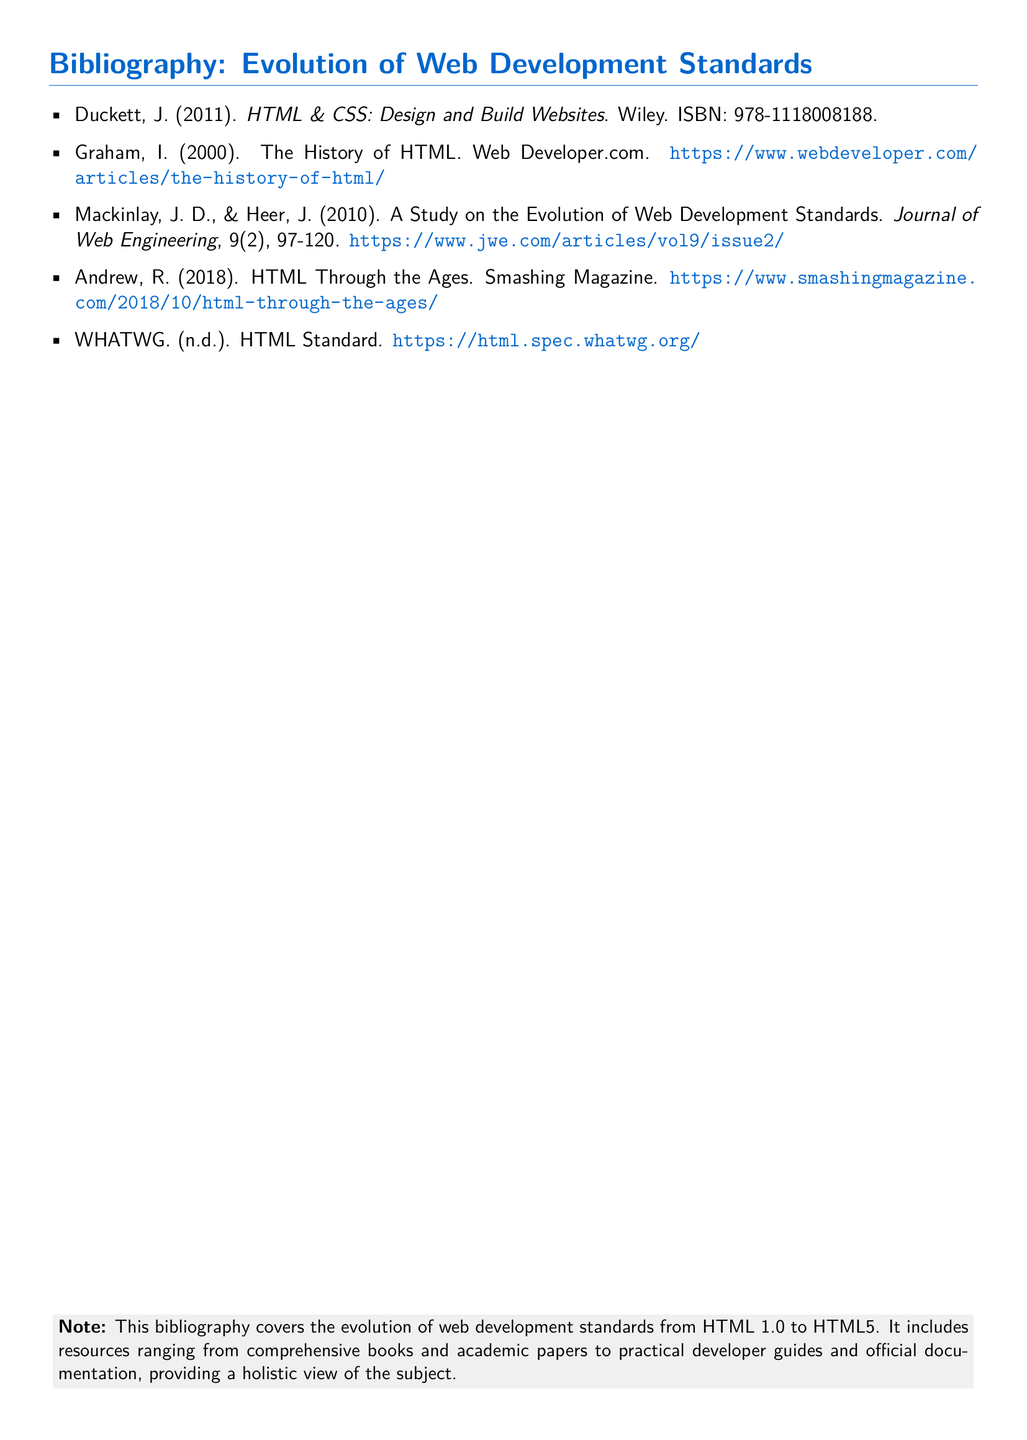What is the title of the first reference? The first reference in the document is titled "HTML & CSS: Design and Build Websites".
Answer: HTML & CSS: Design and Build Websites Who is the author of the second reference? The author listed for the second reference is Ian Graham.
Answer: Ian Graham What year was the book by Duckett published? The book by Duckett was published in 2011.
Answer: 2011 What type of resource is provided by WHATWG? WHATWG provides the official HTML Standard.
Answer: HTML Standard How many references are listed in the bibliography? The number of references in the bibliography is five.
Answer: five Which publication featured the article "HTML Through the Ages"? The article "HTML Through the Ages" was featured in Smashing Magazine.
Answer: Smashing Magazine What is the URL for the HTML Standard? The URL mentioned for the HTML Standard is https://html.spec.whatwg.org/.
Answer: https://html.spec.whatwg.org/ What is the main topic covered by the bibliography? The main topic covered by the bibliography is the evolution of web development standards from HTML 1.0 to HTML5.
Answer: evolution of web development standards from HTML 1.0 to HTML5 